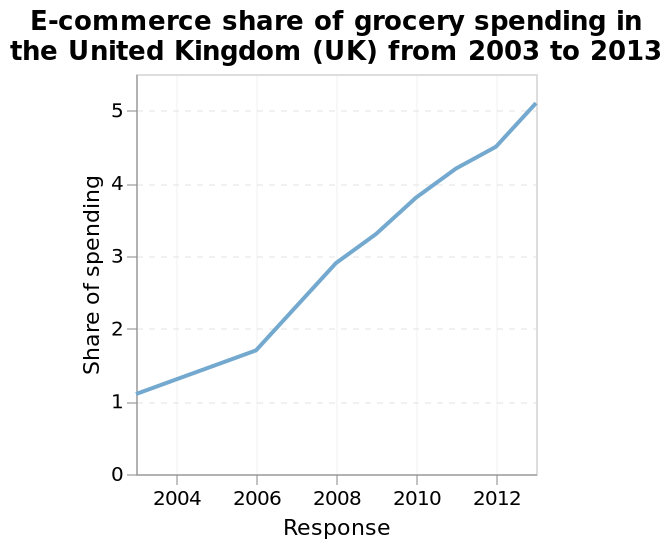<image>
What is the label of the line diagram? The line diagram is labeled "E-commerce share of grocery spending in the United Kingdom (UK) from 2003 to 2013." Does the graph show a continuous increase over time? Yes, the graph appears to continually increase. 